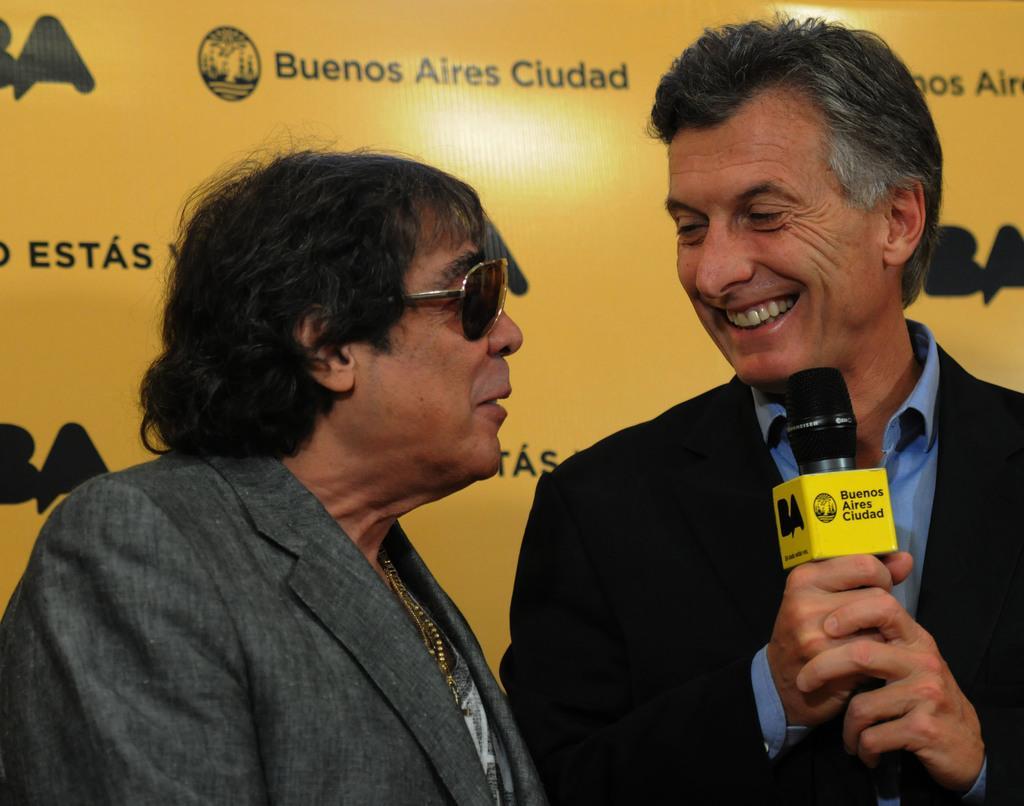Can you describe this image briefly? In the picture there are two men, they are talking to each other and the second person is holding a mic in his hand, behind the men there is a banner with some names on it. 